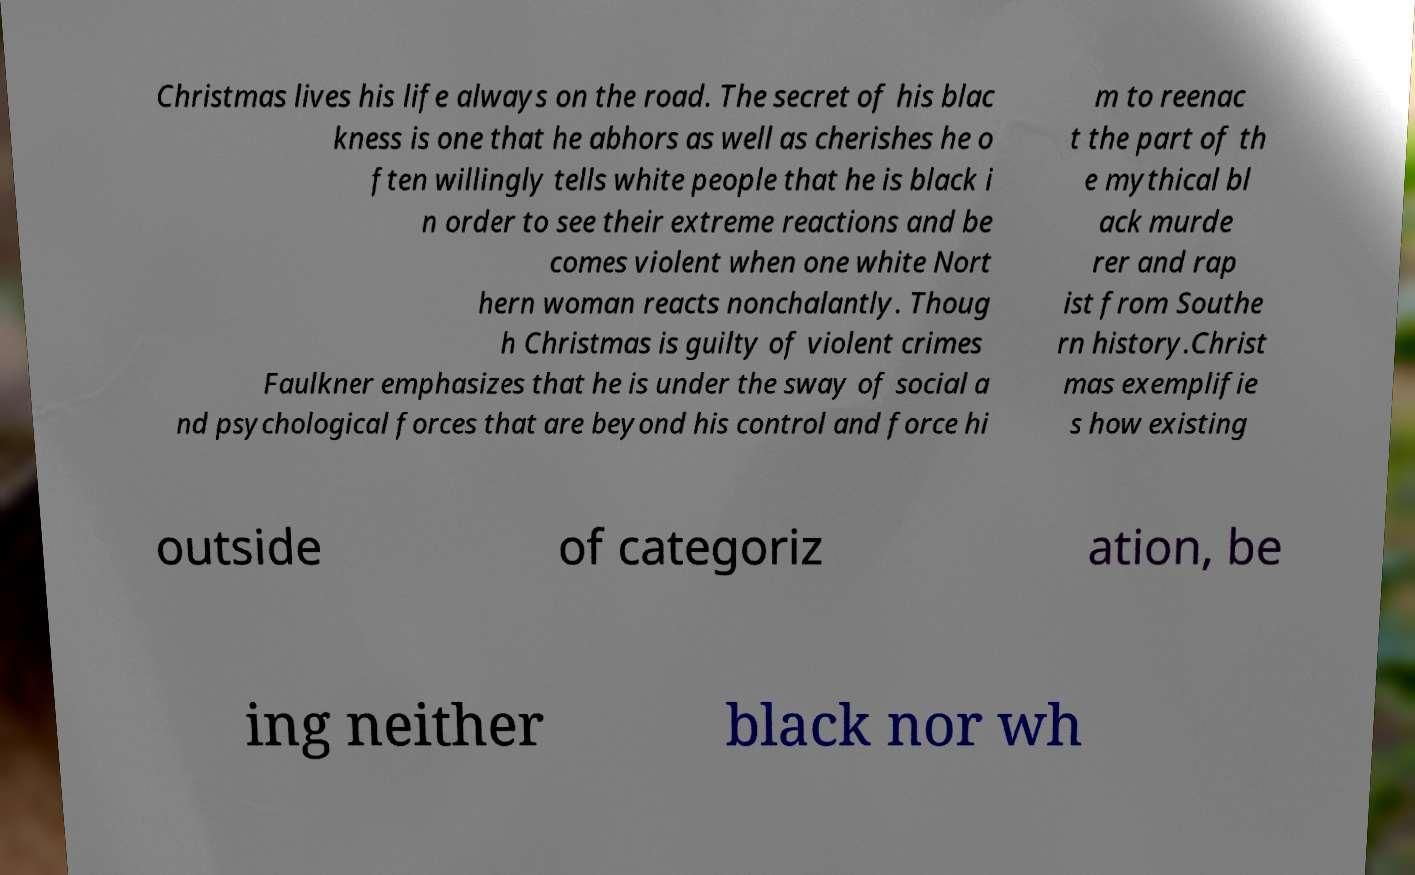There's text embedded in this image that I need extracted. Can you transcribe it verbatim? Christmas lives his life always on the road. The secret of his blac kness is one that he abhors as well as cherishes he o ften willingly tells white people that he is black i n order to see their extreme reactions and be comes violent when one white Nort hern woman reacts nonchalantly. Thoug h Christmas is guilty of violent crimes Faulkner emphasizes that he is under the sway of social a nd psychological forces that are beyond his control and force hi m to reenac t the part of th e mythical bl ack murde rer and rap ist from Southe rn history.Christ mas exemplifie s how existing outside of categoriz ation, be ing neither black nor wh 